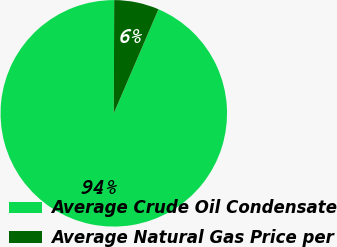Convert chart. <chart><loc_0><loc_0><loc_500><loc_500><pie_chart><fcel>Average Crude Oil Condensate<fcel>Average Natural Gas Price per<nl><fcel>93.6%<fcel>6.4%<nl></chart> 